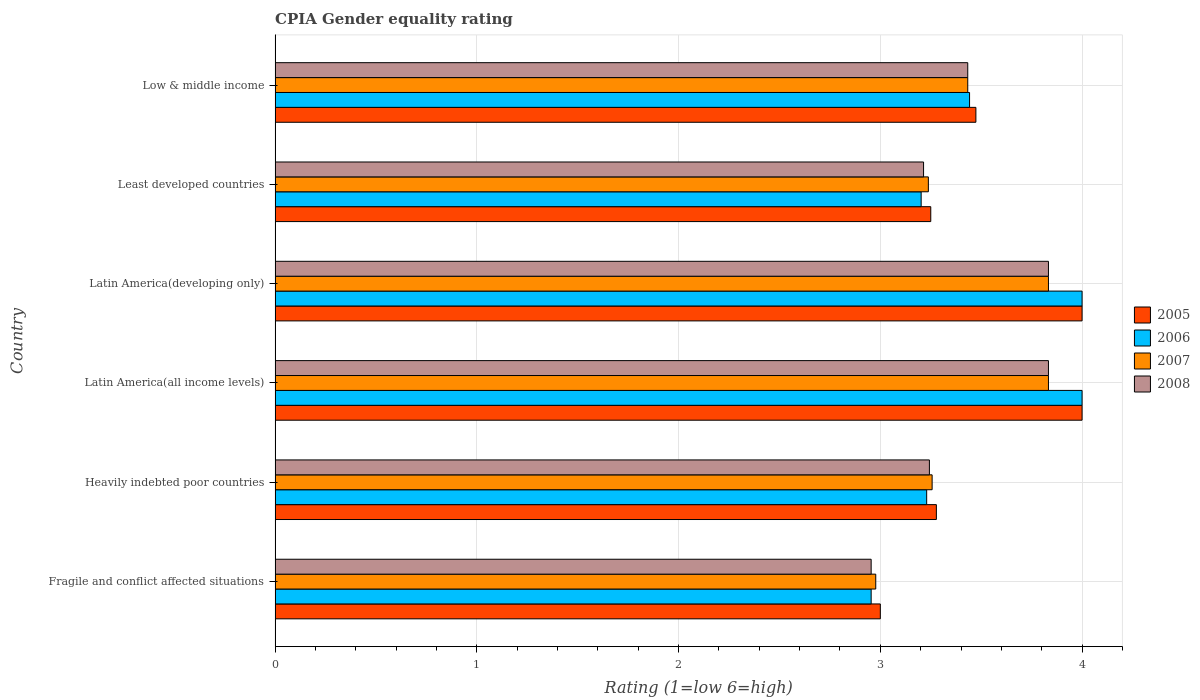How many different coloured bars are there?
Your answer should be compact. 4. How many groups of bars are there?
Provide a succinct answer. 6. Are the number of bars per tick equal to the number of legend labels?
Your response must be concise. Yes. How many bars are there on the 4th tick from the top?
Offer a very short reply. 4. How many bars are there on the 2nd tick from the bottom?
Make the answer very short. 4. What is the label of the 5th group of bars from the top?
Ensure brevity in your answer.  Heavily indebted poor countries. Across all countries, what is the minimum CPIA rating in 2005?
Offer a very short reply. 3. In which country was the CPIA rating in 2006 maximum?
Provide a succinct answer. Latin America(all income levels). In which country was the CPIA rating in 2006 minimum?
Ensure brevity in your answer.  Fragile and conflict affected situations. What is the total CPIA rating in 2008 in the graph?
Offer a very short reply. 20.51. What is the difference between the CPIA rating in 2006 in Fragile and conflict affected situations and that in Latin America(developing only)?
Give a very brief answer. -1.05. What is the difference between the CPIA rating in 2005 in Latin America(developing only) and the CPIA rating in 2007 in Low & middle income?
Make the answer very short. 0.57. What is the average CPIA rating in 2006 per country?
Offer a very short reply. 3.47. What is the difference between the CPIA rating in 2005 and CPIA rating in 2008 in Latin America(all income levels)?
Provide a succinct answer. 0.17. What is the ratio of the CPIA rating in 2006 in Heavily indebted poor countries to that in Least developed countries?
Provide a succinct answer. 1.01. Is the difference between the CPIA rating in 2005 in Latin America(all income levels) and Least developed countries greater than the difference between the CPIA rating in 2008 in Latin America(all income levels) and Least developed countries?
Provide a short and direct response. Yes. What is the difference between the highest and the lowest CPIA rating in 2006?
Give a very brief answer. 1.05. In how many countries, is the CPIA rating in 2007 greater than the average CPIA rating in 2007 taken over all countries?
Give a very brief answer. 3. Is it the case that in every country, the sum of the CPIA rating in 2008 and CPIA rating in 2006 is greater than the CPIA rating in 2005?
Make the answer very short. Yes. What is the difference between two consecutive major ticks on the X-axis?
Provide a short and direct response. 1. Where does the legend appear in the graph?
Your answer should be very brief. Center right. How are the legend labels stacked?
Your answer should be very brief. Vertical. What is the title of the graph?
Provide a short and direct response. CPIA Gender equality rating. Does "1999" appear as one of the legend labels in the graph?
Offer a very short reply. No. What is the Rating (1=low 6=high) of 2006 in Fragile and conflict affected situations?
Your answer should be very brief. 2.95. What is the Rating (1=low 6=high) in 2007 in Fragile and conflict affected situations?
Keep it short and to the point. 2.98. What is the Rating (1=low 6=high) in 2008 in Fragile and conflict affected situations?
Your response must be concise. 2.95. What is the Rating (1=low 6=high) in 2005 in Heavily indebted poor countries?
Your response must be concise. 3.28. What is the Rating (1=low 6=high) in 2006 in Heavily indebted poor countries?
Give a very brief answer. 3.23. What is the Rating (1=low 6=high) of 2007 in Heavily indebted poor countries?
Make the answer very short. 3.26. What is the Rating (1=low 6=high) of 2008 in Heavily indebted poor countries?
Your response must be concise. 3.24. What is the Rating (1=low 6=high) in 2005 in Latin America(all income levels)?
Offer a terse response. 4. What is the Rating (1=low 6=high) of 2007 in Latin America(all income levels)?
Provide a short and direct response. 3.83. What is the Rating (1=low 6=high) of 2008 in Latin America(all income levels)?
Provide a succinct answer. 3.83. What is the Rating (1=low 6=high) in 2005 in Latin America(developing only)?
Your answer should be compact. 4. What is the Rating (1=low 6=high) in 2006 in Latin America(developing only)?
Make the answer very short. 4. What is the Rating (1=low 6=high) in 2007 in Latin America(developing only)?
Give a very brief answer. 3.83. What is the Rating (1=low 6=high) of 2008 in Latin America(developing only)?
Make the answer very short. 3.83. What is the Rating (1=low 6=high) of 2006 in Least developed countries?
Offer a very short reply. 3.2. What is the Rating (1=low 6=high) of 2007 in Least developed countries?
Your response must be concise. 3.24. What is the Rating (1=low 6=high) of 2008 in Least developed countries?
Provide a succinct answer. 3.21. What is the Rating (1=low 6=high) of 2005 in Low & middle income?
Provide a succinct answer. 3.47. What is the Rating (1=low 6=high) of 2006 in Low & middle income?
Provide a short and direct response. 3.44. What is the Rating (1=low 6=high) of 2007 in Low & middle income?
Your answer should be compact. 3.43. What is the Rating (1=low 6=high) of 2008 in Low & middle income?
Offer a terse response. 3.43. Across all countries, what is the maximum Rating (1=low 6=high) in 2007?
Your answer should be very brief. 3.83. Across all countries, what is the maximum Rating (1=low 6=high) in 2008?
Make the answer very short. 3.83. Across all countries, what is the minimum Rating (1=low 6=high) in 2006?
Keep it short and to the point. 2.95. Across all countries, what is the minimum Rating (1=low 6=high) in 2007?
Your answer should be very brief. 2.98. Across all countries, what is the minimum Rating (1=low 6=high) in 2008?
Your answer should be compact. 2.95. What is the total Rating (1=low 6=high) of 2005 in the graph?
Offer a terse response. 21. What is the total Rating (1=low 6=high) of 2006 in the graph?
Provide a succinct answer. 20.83. What is the total Rating (1=low 6=high) of 2007 in the graph?
Your answer should be very brief. 20.57. What is the total Rating (1=low 6=high) in 2008 in the graph?
Your answer should be very brief. 20.51. What is the difference between the Rating (1=low 6=high) in 2005 in Fragile and conflict affected situations and that in Heavily indebted poor countries?
Keep it short and to the point. -0.28. What is the difference between the Rating (1=low 6=high) of 2006 in Fragile and conflict affected situations and that in Heavily indebted poor countries?
Your response must be concise. -0.28. What is the difference between the Rating (1=low 6=high) of 2007 in Fragile and conflict affected situations and that in Heavily indebted poor countries?
Your response must be concise. -0.28. What is the difference between the Rating (1=low 6=high) of 2008 in Fragile and conflict affected situations and that in Heavily indebted poor countries?
Keep it short and to the point. -0.29. What is the difference between the Rating (1=low 6=high) in 2005 in Fragile and conflict affected situations and that in Latin America(all income levels)?
Keep it short and to the point. -1. What is the difference between the Rating (1=low 6=high) of 2006 in Fragile and conflict affected situations and that in Latin America(all income levels)?
Make the answer very short. -1.05. What is the difference between the Rating (1=low 6=high) of 2007 in Fragile and conflict affected situations and that in Latin America(all income levels)?
Provide a short and direct response. -0.86. What is the difference between the Rating (1=low 6=high) of 2008 in Fragile and conflict affected situations and that in Latin America(all income levels)?
Your response must be concise. -0.88. What is the difference between the Rating (1=low 6=high) of 2006 in Fragile and conflict affected situations and that in Latin America(developing only)?
Keep it short and to the point. -1.05. What is the difference between the Rating (1=low 6=high) of 2007 in Fragile and conflict affected situations and that in Latin America(developing only)?
Make the answer very short. -0.86. What is the difference between the Rating (1=low 6=high) of 2008 in Fragile and conflict affected situations and that in Latin America(developing only)?
Make the answer very short. -0.88. What is the difference between the Rating (1=low 6=high) in 2006 in Fragile and conflict affected situations and that in Least developed countries?
Offer a terse response. -0.25. What is the difference between the Rating (1=low 6=high) of 2007 in Fragile and conflict affected situations and that in Least developed countries?
Ensure brevity in your answer.  -0.26. What is the difference between the Rating (1=low 6=high) of 2008 in Fragile and conflict affected situations and that in Least developed countries?
Offer a very short reply. -0.26. What is the difference between the Rating (1=low 6=high) of 2005 in Fragile and conflict affected situations and that in Low & middle income?
Offer a very short reply. -0.47. What is the difference between the Rating (1=low 6=high) in 2006 in Fragile and conflict affected situations and that in Low & middle income?
Offer a very short reply. -0.49. What is the difference between the Rating (1=low 6=high) of 2007 in Fragile and conflict affected situations and that in Low & middle income?
Your answer should be compact. -0.46. What is the difference between the Rating (1=low 6=high) in 2008 in Fragile and conflict affected situations and that in Low & middle income?
Offer a terse response. -0.48. What is the difference between the Rating (1=low 6=high) in 2005 in Heavily indebted poor countries and that in Latin America(all income levels)?
Your answer should be compact. -0.72. What is the difference between the Rating (1=low 6=high) of 2006 in Heavily indebted poor countries and that in Latin America(all income levels)?
Offer a very short reply. -0.77. What is the difference between the Rating (1=low 6=high) of 2007 in Heavily indebted poor countries and that in Latin America(all income levels)?
Provide a succinct answer. -0.58. What is the difference between the Rating (1=low 6=high) of 2008 in Heavily indebted poor countries and that in Latin America(all income levels)?
Provide a short and direct response. -0.59. What is the difference between the Rating (1=low 6=high) in 2005 in Heavily indebted poor countries and that in Latin America(developing only)?
Make the answer very short. -0.72. What is the difference between the Rating (1=low 6=high) in 2006 in Heavily indebted poor countries and that in Latin America(developing only)?
Offer a very short reply. -0.77. What is the difference between the Rating (1=low 6=high) in 2007 in Heavily indebted poor countries and that in Latin America(developing only)?
Ensure brevity in your answer.  -0.58. What is the difference between the Rating (1=low 6=high) in 2008 in Heavily indebted poor countries and that in Latin America(developing only)?
Make the answer very short. -0.59. What is the difference between the Rating (1=low 6=high) in 2005 in Heavily indebted poor countries and that in Least developed countries?
Ensure brevity in your answer.  0.03. What is the difference between the Rating (1=low 6=high) of 2006 in Heavily indebted poor countries and that in Least developed countries?
Make the answer very short. 0.03. What is the difference between the Rating (1=low 6=high) of 2007 in Heavily indebted poor countries and that in Least developed countries?
Keep it short and to the point. 0.02. What is the difference between the Rating (1=low 6=high) in 2008 in Heavily indebted poor countries and that in Least developed countries?
Your answer should be very brief. 0.03. What is the difference between the Rating (1=low 6=high) in 2005 in Heavily indebted poor countries and that in Low & middle income?
Ensure brevity in your answer.  -0.2. What is the difference between the Rating (1=low 6=high) of 2006 in Heavily indebted poor countries and that in Low & middle income?
Your answer should be very brief. -0.21. What is the difference between the Rating (1=low 6=high) of 2007 in Heavily indebted poor countries and that in Low & middle income?
Your answer should be very brief. -0.18. What is the difference between the Rating (1=low 6=high) in 2008 in Heavily indebted poor countries and that in Low & middle income?
Keep it short and to the point. -0.19. What is the difference between the Rating (1=low 6=high) of 2006 in Latin America(all income levels) and that in Latin America(developing only)?
Provide a succinct answer. 0. What is the difference between the Rating (1=low 6=high) in 2007 in Latin America(all income levels) and that in Latin America(developing only)?
Give a very brief answer. 0. What is the difference between the Rating (1=low 6=high) in 2006 in Latin America(all income levels) and that in Least developed countries?
Ensure brevity in your answer.  0.8. What is the difference between the Rating (1=low 6=high) in 2007 in Latin America(all income levels) and that in Least developed countries?
Provide a short and direct response. 0.6. What is the difference between the Rating (1=low 6=high) in 2008 in Latin America(all income levels) and that in Least developed countries?
Give a very brief answer. 0.62. What is the difference between the Rating (1=low 6=high) of 2005 in Latin America(all income levels) and that in Low & middle income?
Offer a very short reply. 0.53. What is the difference between the Rating (1=low 6=high) in 2006 in Latin America(all income levels) and that in Low & middle income?
Your response must be concise. 0.56. What is the difference between the Rating (1=low 6=high) of 2007 in Latin America(all income levels) and that in Low & middle income?
Make the answer very short. 0.4. What is the difference between the Rating (1=low 6=high) in 2006 in Latin America(developing only) and that in Least developed countries?
Offer a very short reply. 0.8. What is the difference between the Rating (1=low 6=high) of 2007 in Latin America(developing only) and that in Least developed countries?
Give a very brief answer. 0.6. What is the difference between the Rating (1=low 6=high) in 2008 in Latin America(developing only) and that in Least developed countries?
Give a very brief answer. 0.62. What is the difference between the Rating (1=low 6=high) of 2005 in Latin America(developing only) and that in Low & middle income?
Your response must be concise. 0.53. What is the difference between the Rating (1=low 6=high) of 2006 in Latin America(developing only) and that in Low & middle income?
Ensure brevity in your answer.  0.56. What is the difference between the Rating (1=low 6=high) of 2007 in Latin America(developing only) and that in Low & middle income?
Offer a very short reply. 0.4. What is the difference between the Rating (1=low 6=high) in 2008 in Latin America(developing only) and that in Low & middle income?
Provide a succinct answer. 0.4. What is the difference between the Rating (1=low 6=high) in 2005 in Least developed countries and that in Low & middle income?
Your response must be concise. -0.22. What is the difference between the Rating (1=low 6=high) in 2006 in Least developed countries and that in Low & middle income?
Make the answer very short. -0.24. What is the difference between the Rating (1=low 6=high) in 2007 in Least developed countries and that in Low & middle income?
Your response must be concise. -0.2. What is the difference between the Rating (1=low 6=high) in 2008 in Least developed countries and that in Low & middle income?
Your answer should be compact. -0.22. What is the difference between the Rating (1=low 6=high) in 2005 in Fragile and conflict affected situations and the Rating (1=low 6=high) in 2006 in Heavily indebted poor countries?
Offer a terse response. -0.23. What is the difference between the Rating (1=low 6=high) in 2005 in Fragile and conflict affected situations and the Rating (1=low 6=high) in 2007 in Heavily indebted poor countries?
Keep it short and to the point. -0.26. What is the difference between the Rating (1=low 6=high) of 2005 in Fragile and conflict affected situations and the Rating (1=low 6=high) of 2008 in Heavily indebted poor countries?
Provide a short and direct response. -0.24. What is the difference between the Rating (1=low 6=high) in 2006 in Fragile and conflict affected situations and the Rating (1=low 6=high) in 2007 in Heavily indebted poor countries?
Make the answer very short. -0.3. What is the difference between the Rating (1=low 6=high) in 2006 in Fragile and conflict affected situations and the Rating (1=low 6=high) in 2008 in Heavily indebted poor countries?
Offer a very short reply. -0.29. What is the difference between the Rating (1=low 6=high) in 2007 in Fragile and conflict affected situations and the Rating (1=low 6=high) in 2008 in Heavily indebted poor countries?
Give a very brief answer. -0.27. What is the difference between the Rating (1=low 6=high) of 2005 in Fragile and conflict affected situations and the Rating (1=low 6=high) of 2007 in Latin America(all income levels)?
Offer a terse response. -0.83. What is the difference between the Rating (1=low 6=high) of 2005 in Fragile and conflict affected situations and the Rating (1=low 6=high) of 2008 in Latin America(all income levels)?
Your response must be concise. -0.83. What is the difference between the Rating (1=low 6=high) of 2006 in Fragile and conflict affected situations and the Rating (1=low 6=high) of 2007 in Latin America(all income levels)?
Your answer should be very brief. -0.88. What is the difference between the Rating (1=low 6=high) of 2006 in Fragile and conflict affected situations and the Rating (1=low 6=high) of 2008 in Latin America(all income levels)?
Provide a short and direct response. -0.88. What is the difference between the Rating (1=low 6=high) of 2007 in Fragile and conflict affected situations and the Rating (1=low 6=high) of 2008 in Latin America(all income levels)?
Your response must be concise. -0.86. What is the difference between the Rating (1=low 6=high) in 2005 in Fragile and conflict affected situations and the Rating (1=low 6=high) in 2006 in Latin America(developing only)?
Give a very brief answer. -1. What is the difference between the Rating (1=low 6=high) of 2006 in Fragile and conflict affected situations and the Rating (1=low 6=high) of 2007 in Latin America(developing only)?
Ensure brevity in your answer.  -0.88. What is the difference between the Rating (1=low 6=high) of 2006 in Fragile and conflict affected situations and the Rating (1=low 6=high) of 2008 in Latin America(developing only)?
Give a very brief answer. -0.88. What is the difference between the Rating (1=low 6=high) of 2007 in Fragile and conflict affected situations and the Rating (1=low 6=high) of 2008 in Latin America(developing only)?
Give a very brief answer. -0.86. What is the difference between the Rating (1=low 6=high) in 2005 in Fragile and conflict affected situations and the Rating (1=low 6=high) in 2006 in Least developed countries?
Your answer should be compact. -0.2. What is the difference between the Rating (1=low 6=high) in 2005 in Fragile and conflict affected situations and the Rating (1=low 6=high) in 2007 in Least developed countries?
Provide a succinct answer. -0.24. What is the difference between the Rating (1=low 6=high) in 2005 in Fragile and conflict affected situations and the Rating (1=low 6=high) in 2008 in Least developed countries?
Offer a very short reply. -0.21. What is the difference between the Rating (1=low 6=high) in 2006 in Fragile and conflict affected situations and the Rating (1=low 6=high) in 2007 in Least developed countries?
Your response must be concise. -0.28. What is the difference between the Rating (1=low 6=high) in 2006 in Fragile and conflict affected situations and the Rating (1=low 6=high) in 2008 in Least developed countries?
Your response must be concise. -0.26. What is the difference between the Rating (1=low 6=high) of 2007 in Fragile and conflict affected situations and the Rating (1=low 6=high) of 2008 in Least developed countries?
Offer a very short reply. -0.24. What is the difference between the Rating (1=low 6=high) in 2005 in Fragile and conflict affected situations and the Rating (1=low 6=high) in 2006 in Low & middle income?
Make the answer very short. -0.44. What is the difference between the Rating (1=low 6=high) in 2005 in Fragile and conflict affected situations and the Rating (1=low 6=high) in 2007 in Low & middle income?
Ensure brevity in your answer.  -0.43. What is the difference between the Rating (1=low 6=high) of 2005 in Fragile and conflict affected situations and the Rating (1=low 6=high) of 2008 in Low & middle income?
Provide a succinct answer. -0.43. What is the difference between the Rating (1=low 6=high) of 2006 in Fragile and conflict affected situations and the Rating (1=low 6=high) of 2007 in Low & middle income?
Your answer should be compact. -0.48. What is the difference between the Rating (1=low 6=high) in 2006 in Fragile and conflict affected situations and the Rating (1=low 6=high) in 2008 in Low & middle income?
Make the answer very short. -0.48. What is the difference between the Rating (1=low 6=high) in 2007 in Fragile and conflict affected situations and the Rating (1=low 6=high) in 2008 in Low & middle income?
Your response must be concise. -0.46. What is the difference between the Rating (1=low 6=high) of 2005 in Heavily indebted poor countries and the Rating (1=low 6=high) of 2006 in Latin America(all income levels)?
Make the answer very short. -0.72. What is the difference between the Rating (1=low 6=high) in 2005 in Heavily indebted poor countries and the Rating (1=low 6=high) in 2007 in Latin America(all income levels)?
Ensure brevity in your answer.  -0.56. What is the difference between the Rating (1=low 6=high) of 2005 in Heavily indebted poor countries and the Rating (1=low 6=high) of 2008 in Latin America(all income levels)?
Provide a succinct answer. -0.56. What is the difference between the Rating (1=low 6=high) in 2006 in Heavily indebted poor countries and the Rating (1=low 6=high) in 2007 in Latin America(all income levels)?
Make the answer very short. -0.6. What is the difference between the Rating (1=low 6=high) in 2006 in Heavily indebted poor countries and the Rating (1=low 6=high) in 2008 in Latin America(all income levels)?
Your answer should be compact. -0.6. What is the difference between the Rating (1=low 6=high) of 2007 in Heavily indebted poor countries and the Rating (1=low 6=high) of 2008 in Latin America(all income levels)?
Provide a short and direct response. -0.58. What is the difference between the Rating (1=low 6=high) of 2005 in Heavily indebted poor countries and the Rating (1=low 6=high) of 2006 in Latin America(developing only)?
Provide a succinct answer. -0.72. What is the difference between the Rating (1=low 6=high) of 2005 in Heavily indebted poor countries and the Rating (1=low 6=high) of 2007 in Latin America(developing only)?
Offer a very short reply. -0.56. What is the difference between the Rating (1=low 6=high) of 2005 in Heavily indebted poor countries and the Rating (1=low 6=high) of 2008 in Latin America(developing only)?
Provide a short and direct response. -0.56. What is the difference between the Rating (1=low 6=high) in 2006 in Heavily indebted poor countries and the Rating (1=low 6=high) in 2007 in Latin America(developing only)?
Keep it short and to the point. -0.6. What is the difference between the Rating (1=low 6=high) in 2006 in Heavily indebted poor countries and the Rating (1=low 6=high) in 2008 in Latin America(developing only)?
Offer a very short reply. -0.6. What is the difference between the Rating (1=low 6=high) in 2007 in Heavily indebted poor countries and the Rating (1=low 6=high) in 2008 in Latin America(developing only)?
Keep it short and to the point. -0.58. What is the difference between the Rating (1=low 6=high) in 2005 in Heavily indebted poor countries and the Rating (1=low 6=high) in 2006 in Least developed countries?
Make the answer very short. 0.08. What is the difference between the Rating (1=low 6=high) in 2005 in Heavily indebted poor countries and the Rating (1=low 6=high) in 2007 in Least developed countries?
Make the answer very short. 0.04. What is the difference between the Rating (1=low 6=high) of 2005 in Heavily indebted poor countries and the Rating (1=low 6=high) of 2008 in Least developed countries?
Your answer should be compact. 0.06. What is the difference between the Rating (1=low 6=high) in 2006 in Heavily indebted poor countries and the Rating (1=low 6=high) in 2007 in Least developed countries?
Provide a short and direct response. -0.01. What is the difference between the Rating (1=low 6=high) in 2006 in Heavily indebted poor countries and the Rating (1=low 6=high) in 2008 in Least developed countries?
Offer a very short reply. 0.02. What is the difference between the Rating (1=low 6=high) of 2007 in Heavily indebted poor countries and the Rating (1=low 6=high) of 2008 in Least developed countries?
Your answer should be compact. 0.04. What is the difference between the Rating (1=low 6=high) in 2005 in Heavily indebted poor countries and the Rating (1=low 6=high) in 2006 in Low & middle income?
Ensure brevity in your answer.  -0.16. What is the difference between the Rating (1=low 6=high) of 2005 in Heavily indebted poor countries and the Rating (1=low 6=high) of 2007 in Low & middle income?
Keep it short and to the point. -0.16. What is the difference between the Rating (1=low 6=high) in 2005 in Heavily indebted poor countries and the Rating (1=low 6=high) in 2008 in Low & middle income?
Your response must be concise. -0.16. What is the difference between the Rating (1=low 6=high) in 2006 in Heavily indebted poor countries and the Rating (1=low 6=high) in 2007 in Low & middle income?
Give a very brief answer. -0.2. What is the difference between the Rating (1=low 6=high) of 2006 in Heavily indebted poor countries and the Rating (1=low 6=high) of 2008 in Low & middle income?
Provide a short and direct response. -0.2. What is the difference between the Rating (1=low 6=high) in 2007 in Heavily indebted poor countries and the Rating (1=low 6=high) in 2008 in Low & middle income?
Offer a terse response. -0.18. What is the difference between the Rating (1=low 6=high) in 2006 in Latin America(all income levels) and the Rating (1=low 6=high) in 2007 in Latin America(developing only)?
Provide a short and direct response. 0.17. What is the difference between the Rating (1=low 6=high) of 2007 in Latin America(all income levels) and the Rating (1=low 6=high) of 2008 in Latin America(developing only)?
Your answer should be very brief. 0. What is the difference between the Rating (1=low 6=high) in 2005 in Latin America(all income levels) and the Rating (1=low 6=high) in 2006 in Least developed countries?
Make the answer very short. 0.8. What is the difference between the Rating (1=low 6=high) of 2005 in Latin America(all income levels) and the Rating (1=low 6=high) of 2007 in Least developed countries?
Your response must be concise. 0.76. What is the difference between the Rating (1=low 6=high) of 2005 in Latin America(all income levels) and the Rating (1=low 6=high) of 2008 in Least developed countries?
Give a very brief answer. 0.79. What is the difference between the Rating (1=low 6=high) in 2006 in Latin America(all income levels) and the Rating (1=low 6=high) in 2007 in Least developed countries?
Offer a very short reply. 0.76. What is the difference between the Rating (1=low 6=high) in 2006 in Latin America(all income levels) and the Rating (1=low 6=high) in 2008 in Least developed countries?
Give a very brief answer. 0.79. What is the difference between the Rating (1=low 6=high) in 2007 in Latin America(all income levels) and the Rating (1=low 6=high) in 2008 in Least developed countries?
Provide a succinct answer. 0.62. What is the difference between the Rating (1=low 6=high) of 2005 in Latin America(all income levels) and the Rating (1=low 6=high) of 2006 in Low & middle income?
Make the answer very short. 0.56. What is the difference between the Rating (1=low 6=high) of 2005 in Latin America(all income levels) and the Rating (1=low 6=high) of 2007 in Low & middle income?
Give a very brief answer. 0.57. What is the difference between the Rating (1=low 6=high) of 2005 in Latin America(all income levels) and the Rating (1=low 6=high) of 2008 in Low & middle income?
Ensure brevity in your answer.  0.57. What is the difference between the Rating (1=low 6=high) of 2006 in Latin America(all income levels) and the Rating (1=low 6=high) of 2007 in Low & middle income?
Your response must be concise. 0.57. What is the difference between the Rating (1=low 6=high) in 2006 in Latin America(all income levels) and the Rating (1=low 6=high) in 2008 in Low & middle income?
Give a very brief answer. 0.57. What is the difference between the Rating (1=low 6=high) of 2007 in Latin America(all income levels) and the Rating (1=low 6=high) of 2008 in Low & middle income?
Keep it short and to the point. 0.4. What is the difference between the Rating (1=low 6=high) in 2005 in Latin America(developing only) and the Rating (1=low 6=high) in 2006 in Least developed countries?
Make the answer very short. 0.8. What is the difference between the Rating (1=low 6=high) in 2005 in Latin America(developing only) and the Rating (1=low 6=high) in 2007 in Least developed countries?
Ensure brevity in your answer.  0.76. What is the difference between the Rating (1=low 6=high) in 2005 in Latin America(developing only) and the Rating (1=low 6=high) in 2008 in Least developed countries?
Make the answer very short. 0.79. What is the difference between the Rating (1=low 6=high) of 2006 in Latin America(developing only) and the Rating (1=low 6=high) of 2007 in Least developed countries?
Your answer should be compact. 0.76. What is the difference between the Rating (1=low 6=high) in 2006 in Latin America(developing only) and the Rating (1=low 6=high) in 2008 in Least developed countries?
Your response must be concise. 0.79. What is the difference between the Rating (1=low 6=high) of 2007 in Latin America(developing only) and the Rating (1=low 6=high) of 2008 in Least developed countries?
Give a very brief answer. 0.62. What is the difference between the Rating (1=low 6=high) of 2005 in Latin America(developing only) and the Rating (1=low 6=high) of 2006 in Low & middle income?
Ensure brevity in your answer.  0.56. What is the difference between the Rating (1=low 6=high) in 2005 in Latin America(developing only) and the Rating (1=low 6=high) in 2007 in Low & middle income?
Make the answer very short. 0.57. What is the difference between the Rating (1=low 6=high) in 2005 in Latin America(developing only) and the Rating (1=low 6=high) in 2008 in Low & middle income?
Offer a terse response. 0.57. What is the difference between the Rating (1=low 6=high) in 2006 in Latin America(developing only) and the Rating (1=low 6=high) in 2007 in Low & middle income?
Your answer should be compact. 0.57. What is the difference between the Rating (1=low 6=high) of 2006 in Latin America(developing only) and the Rating (1=low 6=high) of 2008 in Low & middle income?
Your response must be concise. 0.57. What is the difference between the Rating (1=low 6=high) of 2007 in Latin America(developing only) and the Rating (1=low 6=high) of 2008 in Low & middle income?
Ensure brevity in your answer.  0.4. What is the difference between the Rating (1=low 6=high) in 2005 in Least developed countries and the Rating (1=low 6=high) in 2006 in Low & middle income?
Offer a terse response. -0.19. What is the difference between the Rating (1=low 6=high) in 2005 in Least developed countries and the Rating (1=low 6=high) in 2007 in Low & middle income?
Give a very brief answer. -0.18. What is the difference between the Rating (1=low 6=high) in 2005 in Least developed countries and the Rating (1=low 6=high) in 2008 in Low & middle income?
Offer a terse response. -0.18. What is the difference between the Rating (1=low 6=high) of 2006 in Least developed countries and the Rating (1=low 6=high) of 2007 in Low & middle income?
Give a very brief answer. -0.23. What is the difference between the Rating (1=low 6=high) in 2006 in Least developed countries and the Rating (1=low 6=high) in 2008 in Low & middle income?
Ensure brevity in your answer.  -0.23. What is the difference between the Rating (1=low 6=high) in 2007 in Least developed countries and the Rating (1=low 6=high) in 2008 in Low & middle income?
Your answer should be compact. -0.2. What is the average Rating (1=low 6=high) of 2005 per country?
Ensure brevity in your answer.  3.5. What is the average Rating (1=low 6=high) in 2006 per country?
Offer a terse response. 3.47. What is the average Rating (1=low 6=high) in 2007 per country?
Your answer should be very brief. 3.43. What is the average Rating (1=low 6=high) of 2008 per country?
Your answer should be compact. 3.42. What is the difference between the Rating (1=low 6=high) of 2005 and Rating (1=low 6=high) of 2006 in Fragile and conflict affected situations?
Your answer should be very brief. 0.05. What is the difference between the Rating (1=low 6=high) in 2005 and Rating (1=low 6=high) in 2007 in Fragile and conflict affected situations?
Offer a terse response. 0.02. What is the difference between the Rating (1=low 6=high) in 2005 and Rating (1=low 6=high) in 2008 in Fragile and conflict affected situations?
Offer a terse response. 0.05. What is the difference between the Rating (1=low 6=high) in 2006 and Rating (1=low 6=high) in 2007 in Fragile and conflict affected situations?
Offer a very short reply. -0.02. What is the difference between the Rating (1=low 6=high) of 2007 and Rating (1=low 6=high) of 2008 in Fragile and conflict affected situations?
Give a very brief answer. 0.02. What is the difference between the Rating (1=low 6=high) in 2005 and Rating (1=low 6=high) in 2006 in Heavily indebted poor countries?
Offer a terse response. 0.05. What is the difference between the Rating (1=low 6=high) in 2005 and Rating (1=low 6=high) in 2007 in Heavily indebted poor countries?
Provide a short and direct response. 0.02. What is the difference between the Rating (1=low 6=high) in 2005 and Rating (1=low 6=high) in 2008 in Heavily indebted poor countries?
Keep it short and to the point. 0.03. What is the difference between the Rating (1=low 6=high) in 2006 and Rating (1=low 6=high) in 2007 in Heavily indebted poor countries?
Your response must be concise. -0.03. What is the difference between the Rating (1=low 6=high) in 2006 and Rating (1=low 6=high) in 2008 in Heavily indebted poor countries?
Your answer should be compact. -0.01. What is the difference between the Rating (1=low 6=high) of 2007 and Rating (1=low 6=high) of 2008 in Heavily indebted poor countries?
Your answer should be compact. 0.01. What is the difference between the Rating (1=low 6=high) in 2005 and Rating (1=low 6=high) in 2007 in Latin America(all income levels)?
Your response must be concise. 0.17. What is the difference between the Rating (1=low 6=high) in 2006 and Rating (1=low 6=high) in 2007 in Latin America(all income levels)?
Keep it short and to the point. 0.17. What is the difference between the Rating (1=low 6=high) in 2006 and Rating (1=low 6=high) in 2008 in Latin America(all income levels)?
Give a very brief answer. 0.17. What is the difference between the Rating (1=low 6=high) in 2007 and Rating (1=low 6=high) in 2008 in Latin America(all income levels)?
Offer a very short reply. 0. What is the difference between the Rating (1=low 6=high) in 2005 and Rating (1=low 6=high) in 2007 in Latin America(developing only)?
Your answer should be very brief. 0.17. What is the difference between the Rating (1=low 6=high) in 2005 and Rating (1=low 6=high) in 2008 in Latin America(developing only)?
Your response must be concise. 0.17. What is the difference between the Rating (1=low 6=high) of 2006 and Rating (1=low 6=high) of 2008 in Latin America(developing only)?
Provide a succinct answer. 0.17. What is the difference between the Rating (1=low 6=high) in 2005 and Rating (1=low 6=high) in 2006 in Least developed countries?
Give a very brief answer. 0.05. What is the difference between the Rating (1=low 6=high) of 2005 and Rating (1=low 6=high) of 2007 in Least developed countries?
Ensure brevity in your answer.  0.01. What is the difference between the Rating (1=low 6=high) in 2005 and Rating (1=low 6=high) in 2008 in Least developed countries?
Your answer should be compact. 0.04. What is the difference between the Rating (1=low 6=high) of 2006 and Rating (1=low 6=high) of 2007 in Least developed countries?
Your answer should be compact. -0.04. What is the difference between the Rating (1=low 6=high) in 2006 and Rating (1=low 6=high) in 2008 in Least developed countries?
Make the answer very short. -0.01. What is the difference between the Rating (1=low 6=high) in 2007 and Rating (1=low 6=high) in 2008 in Least developed countries?
Your answer should be very brief. 0.02. What is the difference between the Rating (1=low 6=high) of 2005 and Rating (1=low 6=high) of 2006 in Low & middle income?
Make the answer very short. 0.03. What is the difference between the Rating (1=low 6=high) of 2005 and Rating (1=low 6=high) of 2007 in Low & middle income?
Give a very brief answer. 0.04. What is the difference between the Rating (1=low 6=high) in 2005 and Rating (1=low 6=high) in 2008 in Low & middle income?
Your answer should be compact. 0.04. What is the difference between the Rating (1=low 6=high) of 2006 and Rating (1=low 6=high) of 2007 in Low & middle income?
Your answer should be very brief. 0.01. What is the difference between the Rating (1=low 6=high) in 2006 and Rating (1=low 6=high) in 2008 in Low & middle income?
Give a very brief answer. 0.01. What is the difference between the Rating (1=low 6=high) in 2007 and Rating (1=low 6=high) in 2008 in Low & middle income?
Your answer should be very brief. 0. What is the ratio of the Rating (1=low 6=high) of 2005 in Fragile and conflict affected situations to that in Heavily indebted poor countries?
Your answer should be very brief. 0.92. What is the ratio of the Rating (1=low 6=high) of 2006 in Fragile and conflict affected situations to that in Heavily indebted poor countries?
Make the answer very short. 0.91. What is the ratio of the Rating (1=low 6=high) in 2007 in Fragile and conflict affected situations to that in Heavily indebted poor countries?
Ensure brevity in your answer.  0.91. What is the ratio of the Rating (1=low 6=high) in 2008 in Fragile and conflict affected situations to that in Heavily indebted poor countries?
Give a very brief answer. 0.91. What is the ratio of the Rating (1=low 6=high) in 2005 in Fragile and conflict affected situations to that in Latin America(all income levels)?
Offer a very short reply. 0.75. What is the ratio of the Rating (1=low 6=high) of 2006 in Fragile and conflict affected situations to that in Latin America(all income levels)?
Provide a short and direct response. 0.74. What is the ratio of the Rating (1=low 6=high) of 2007 in Fragile and conflict affected situations to that in Latin America(all income levels)?
Give a very brief answer. 0.78. What is the ratio of the Rating (1=low 6=high) in 2008 in Fragile and conflict affected situations to that in Latin America(all income levels)?
Keep it short and to the point. 0.77. What is the ratio of the Rating (1=low 6=high) of 2006 in Fragile and conflict affected situations to that in Latin America(developing only)?
Ensure brevity in your answer.  0.74. What is the ratio of the Rating (1=low 6=high) of 2007 in Fragile and conflict affected situations to that in Latin America(developing only)?
Ensure brevity in your answer.  0.78. What is the ratio of the Rating (1=low 6=high) of 2008 in Fragile and conflict affected situations to that in Latin America(developing only)?
Your response must be concise. 0.77. What is the ratio of the Rating (1=low 6=high) of 2005 in Fragile and conflict affected situations to that in Least developed countries?
Provide a succinct answer. 0.92. What is the ratio of the Rating (1=low 6=high) of 2006 in Fragile and conflict affected situations to that in Least developed countries?
Offer a very short reply. 0.92. What is the ratio of the Rating (1=low 6=high) of 2007 in Fragile and conflict affected situations to that in Least developed countries?
Give a very brief answer. 0.92. What is the ratio of the Rating (1=low 6=high) of 2008 in Fragile and conflict affected situations to that in Least developed countries?
Provide a succinct answer. 0.92. What is the ratio of the Rating (1=low 6=high) in 2005 in Fragile and conflict affected situations to that in Low & middle income?
Provide a succinct answer. 0.86. What is the ratio of the Rating (1=low 6=high) of 2006 in Fragile and conflict affected situations to that in Low & middle income?
Your answer should be compact. 0.86. What is the ratio of the Rating (1=low 6=high) of 2007 in Fragile and conflict affected situations to that in Low & middle income?
Provide a succinct answer. 0.87. What is the ratio of the Rating (1=low 6=high) of 2008 in Fragile and conflict affected situations to that in Low & middle income?
Make the answer very short. 0.86. What is the ratio of the Rating (1=low 6=high) of 2005 in Heavily indebted poor countries to that in Latin America(all income levels)?
Offer a terse response. 0.82. What is the ratio of the Rating (1=low 6=high) of 2006 in Heavily indebted poor countries to that in Latin America(all income levels)?
Keep it short and to the point. 0.81. What is the ratio of the Rating (1=low 6=high) of 2007 in Heavily indebted poor countries to that in Latin America(all income levels)?
Offer a very short reply. 0.85. What is the ratio of the Rating (1=low 6=high) in 2008 in Heavily indebted poor countries to that in Latin America(all income levels)?
Offer a very short reply. 0.85. What is the ratio of the Rating (1=low 6=high) in 2005 in Heavily indebted poor countries to that in Latin America(developing only)?
Offer a very short reply. 0.82. What is the ratio of the Rating (1=low 6=high) of 2006 in Heavily indebted poor countries to that in Latin America(developing only)?
Your answer should be compact. 0.81. What is the ratio of the Rating (1=low 6=high) in 2007 in Heavily indebted poor countries to that in Latin America(developing only)?
Make the answer very short. 0.85. What is the ratio of the Rating (1=low 6=high) in 2008 in Heavily indebted poor countries to that in Latin America(developing only)?
Make the answer very short. 0.85. What is the ratio of the Rating (1=low 6=high) in 2005 in Heavily indebted poor countries to that in Least developed countries?
Provide a succinct answer. 1.01. What is the ratio of the Rating (1=low 6=high) in 2006 in Heavily indebted poor countries to that in Least developed countries?
Your answer should be very brief. 1.01. What is the ratio of the Rating (1=low 6=high) in 2007 in Heavily indebted poor countries to that in Least developed countries?
Offer a very short reply. 1.01. What is the ratio of the Rating (1=low 6=high) in 2005 in Heavily indebted poor countries to that in Low & middle income?
Your answer should be compact. 0.94. What is the ratio of the Rating (1=low 6=high) in 2006 in Heavily indebted poor countries to that in Low & middle income?
Give a very brief answer. 0.94. What is the ratio of the Rating (1=low 6=high) of 2007 in Heavily indebted poor countries to that in Low & middle income?
Offer a very short reply. 0.95. What is the ratio of the Rating (1=low 6=high) in 2008 in Heavily indebted poor countries to that in Low & middle income?
Ensure brevity in your answer.  0.94. What is the ratio of the Rating (1=low 6=high) of 2008 in Latin America(all income levels) to that in Latin America(developing only)?
Give a very brief answer. 1. What is the ratio of the Rating (1=low 6=high) in 2005 in Latin America(all income levels) to that in Least developed countries?
Keep it short and to the point. 1.23. What is the ratio of the Rating (1=low 6=high) in 2006 in Latin America(all income levels) to that in Least developed countries?
Ensure brevity in your answer.  1.25. What is the ratio of the Rating (1=low 6=high) of 2007 in Latin America(all income levels) to that in Least developed countries?
Offer a terse response. 1.18. What is the ratio of the Rating (1=low 6=high) in 2008 in Latin America(all income levels) to that in Least developed countries?
Provide a short and direct response. 1.19. What is the ratio of the Rating (1=low 6=high) of 2005 in Latin America(all income levels) to that in Low & middle income?
Ensure brevity in your answer.  1.15. What is the ratio of the Rating (1=low 6=high) in 2006 in Latin America(all income levels) to that in Low & middle income?
Your answer should be very brief. 1.16. What is the ratio of the Rating (1=low 6=high) in 2007 in Latin America(all income levels) to that in Low & middle income?
Make the answer very short. 1.12. What is the ratio of the Rating (1=low 6=high) of 2008 in Latin America(all income levels) to that in Low & middle income?
Give a very brief answer. 1.12. What is the ratio of the Rating (1=low 6=high) of 2005 in Latin America(developing only) to that in Least developed countries?
Offer a terse response. 1.23. What is the ratio of the Rating (1=low 6=high) of 2006 in Latin America(developing only) to that in Least developed countries?
Keep it short and to the point. 1.25. What is the ratio of the Rating (1=low 6=high) of 2007 in Latin America(developing only) to that in Least developed countries?
Provide a short and direct response. 1.18. What is the ratio of the Rating (1=low 6=high) in 2008 in Latin America(developing only) to that in Least developed countries?
Provide a succinct answer. 1.19. What is the ratio of the Rating (1=low 6=high) in 2005 in Latin America(developing only) to that in Low & middle income?
Ensure brevity in your answer.  1.15. What is the ratio of the Rating (1=low 6=high) of 2006 in Latin America(developing only) to that in Low & middle income?
Make the answer very short. 1.16. What is the ratio of the Rating (1=low 6=high) of 2007 in Latin America(developing only) to that in Low & middle income?
Ensure brevity in your answer.  1.12. What is the ratio of the Rating (1=low 6=high) in 2008 in Latin America(developing only) to that in Low & middle income?
Provide a succinct answer. 1.12. What is the ratio of the Rating (1=low 6=high) in 2005 in Least developed countries to that in Low & middle income?
Offer a very short reply. 0.94. What is the ratio of the Rating (1=low 6=high) of 2006 in Least developed countries to that in Low & middle income?
Provide a succinct answer. 0.93. What is the ratio of the Rating (1=low 6=high) of 2007 in Least developed countries to that in Low & middle income?
Offer a very short reply. 0.94. What is the ratio of the Rating (1=low 6=high) in 2008 in Least developed countries to that in Low & middle income?
Offer a terse response. 0.94. What is the difference between the highest and the second highest Rating (1=low 6=high) in 2005?
Make the answer very short. 0. What is the difference between the highest and the lowest Rating (1=low 6=high) of 2006?
Provide a short and direct response. 1.05. What is the difference between the highest and the lowest Rating (1=low 6=high) of 2007?
Ensure brevity in your answer.  0.86. What is the difference between the highest and the lowest Rating (1=low 6=high) of 2008?
Make the answer very short. 0.88. 